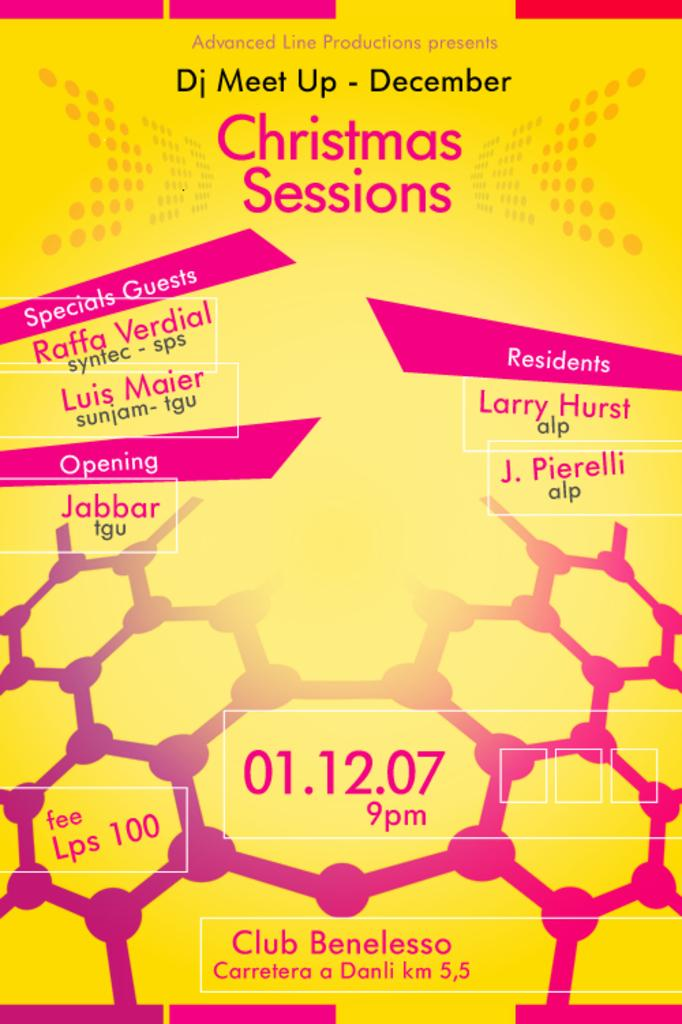<image>
Create a compact narrative representing the image presented. A yellow and pink DJ meet up poster. 